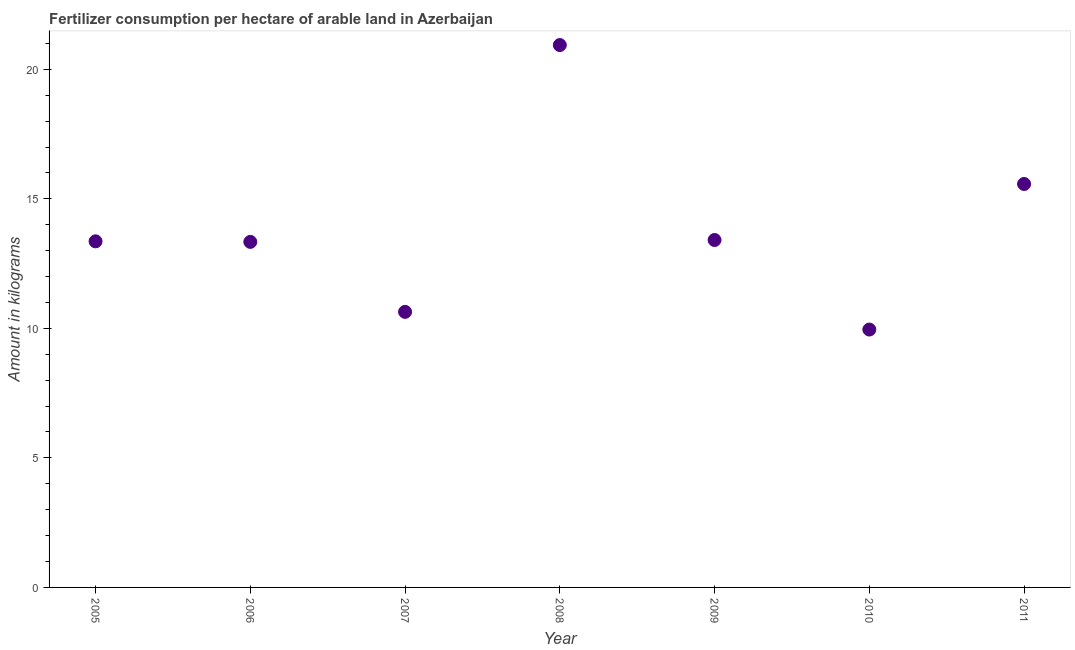What is the amount of fertilizer consumption in 2005?
Offer a very short reply. 13.36. Across all years, what is the maximum amount of fertilizer consumption?
Offer a terse response. 20.94. Across all years, what is the minimum amount of fertilizer consumption?
Make the answer very short. 9.95. In which year was the amount of fertilizer consumption maximum?
Give a very brief answer. 2008. What is the sum of the amount of fertilizer consumption?
Offer a terse response. 97.22. What is the difference between the amount of fertilizer consumption in 2007 and 2011?
Make the answer very short. -4.94. What is the average amount of fertilizer consumption per year?
Keep it short and to the point. 13.89. What is the median amount of fertilizer consumption?
Your answer should be very brief. 13.36. In how many years, is the amount of fertilizer consumption greater than 15 kg?
Offer a terse response. 2. What is the ratio of the amount of fertilizer consumption in 2008 to that in 2011?
Offer a very short reply. 1.34. What is the difference between the highest and the second highest amount of fertilizer consumption?
Provide a succinct answer. 5.36. Is the sum of the amount of fertilizer consumption in 2006 and 2009 greater than the maximum amount of fertilizer consumption across all years?
Offer a very short reply. Yes. What is the difference between the highest and the lowest amount of fertilizer consumption?
Keep it short and to the point. 10.98. Does the amount of fertilizer consumption monotonically increase over the years?
Provide a short and direct response. No. Does the graph contain any zero values?
Provide a short and direct response. No. What is the title of the graph?
Your response must be concise. Fertilizer consumption per hectare of arable land in Azerbaijan . What is the label or title of the Y-axis?
Your response must be concise. Amount in kilograms. What is the Amount in kilograms in 2005?
Provide a succinct answer. 13.36. What is the Amount in kilograms in 2006?
Your answer should be very brief. 13.34. What is the Amount in kilograms in 2007?
Ensure brevity in your answer.  10.64. What is the Amount in kilograms in 2008?
Give a very brief answer. 20.94. What is the Amount in kilograms in 2009?
Provide a short and direct response. 13.41. What is the Amount in kilograms in 2010?
Ensure brevity in your answer.  9.95. What is the Amount in kilograms in 2011?
Provide a succinct answer. 15.57. What is the difference between the Amount in kilograms in 2005 and 2006?
Your response must be concise. 0.02. What is the difference between the Amount in kilograms in 2005 and 2007?
Provide a succinct answer. 2.72. What is the difference between the Amount in kilograms in 2005 and 2008?
Provide a short and direct response. -7.58. What is the difference between the Amount in kilograms in 2005 and 2009?
Provide a succinct answer. -0.05. What is the difference between the Amount in kilograms in 2005 and 2010?
Make the answer very short. 3.41. What is the difference between the Amount in kilograms in 2005 and 2011?
Give a very brief answer. -2.21. What is the difference between the Amount in kilograms in 2006 and 2007?
Provide a short and direct response. 2.7. What is the difference between the Amount in kilograms in 2006 and 2008?
Offer a terse response. -7.6. What is the difference between the Amount in kilograms in 2006 and 2009?
Make the answer very short. -0.07. What is the difference between the Amount in kilograms in 2006 and 2010?
Your answer should be compact. 3.38. What is the difference between the Amount in kilograms in 2006 and 2011?
Ensure brevity in your answer.  -2.24. What is the difference between the Amount in kilograms in 2007 and 2008?
Provide a short and direct response. -10.3. What is the difference between the Amount in kilograms in 2007 and 2009?
Your answer should be compact. -2.77. What is the difference between the Amount in kilograms in 2007 and 2010?
Make the answer very short. 0.68. What is the difference between the Amount in kilograms in 2007 and 2011?
Your answer should be very brief. -4.94. What is the difference between the Amount in kilograms in 2008 and 2009?
Provide a succinct answer. 7.53. What is the difference between the Amount in kilograms in 2008 and 2010?
Your response must be concise. 10.98. What is the difference between the Amount in kilograms in 2008 and 2011?
Provide a short and direct response. 5.36. What is the difference between the Amount in kilograms in 2009 and 2010?
Keep it short and to the point. 3.46. What is the difference between the Amount in kilograms in 2009 and 2011?
Your answer should be very brief. -2.16. What is the difference between the Amount in kilograms in 2010 and 2011?
Ensure brevity in your answer.  -5.62. What is the ratio of the Amount in kilograms in 2005 to that in 2007?
Provide a succinct answer. 1.26. What is the ratio of the Amount in kilograms in 2005 to that in 2008?
Your answer should be very brief. 0.64. What is the ratio of the Amount in kilograms in 2005 to that in 2010?
Ensure brevity in your answer.  1.34. What is the ratio of the Amount in kilograms in 2005 to that in 2011?
Your answer should be very brief. 0.86. What is the ratio of the Amount in kilograms in 2006 to that in 2007?
Keep it short and to the point. 1.25. What is the ratio of the Amount in kilograms in 2006 to that in 2008?
Offer a terse response. 0.64. What is the ratio of the Amount in kilograms in 2006 to that in 2010?
Provide a succinct answer. 1.34. What is the ratio of the Amount in kilograms in 2006 to that in 2011?
Make the answer very short. 0.86. What is the ratio of the Amount in kilograms in 2007 to that in 2008?
Offer a terse response. 0.51. What is the ratio of the Amount in kilograms in 2007 to that in 2009?
Your answer should be very brief. 0.79. What is the ratio of the Amount in kilograms in 2007 to that in 2010?
Offer a very short reply. 1.07. What is the ratio of the Amount in kilograms in 2007 to that in 2011?
Your answer should be very brief. 0.68. What is the ratio of the Amount in kilograms in 2008 to that in 2009?
Keep it short and to the point. 1.56. What is the ratio of the Amount in kilograms in 2008 to that in 2010?
Your answer should be very brief. 2.1. What is the ratio of the Amount in kilograms in 2008 to that in 2011?
Offer a very short reply. 1.34. What is the ratio of the Amount in kilograms in 2009 to that in 2010?
Your response must be concise. 1.35. What is the ratio of the Amount in kilograms in 2009 to that in 2011?
Provide a succinct answer. 0.86. What is the ratio of the Amount in kilograms in 2010 to that in 2011?
Provide a short and direct response. 0.64. 